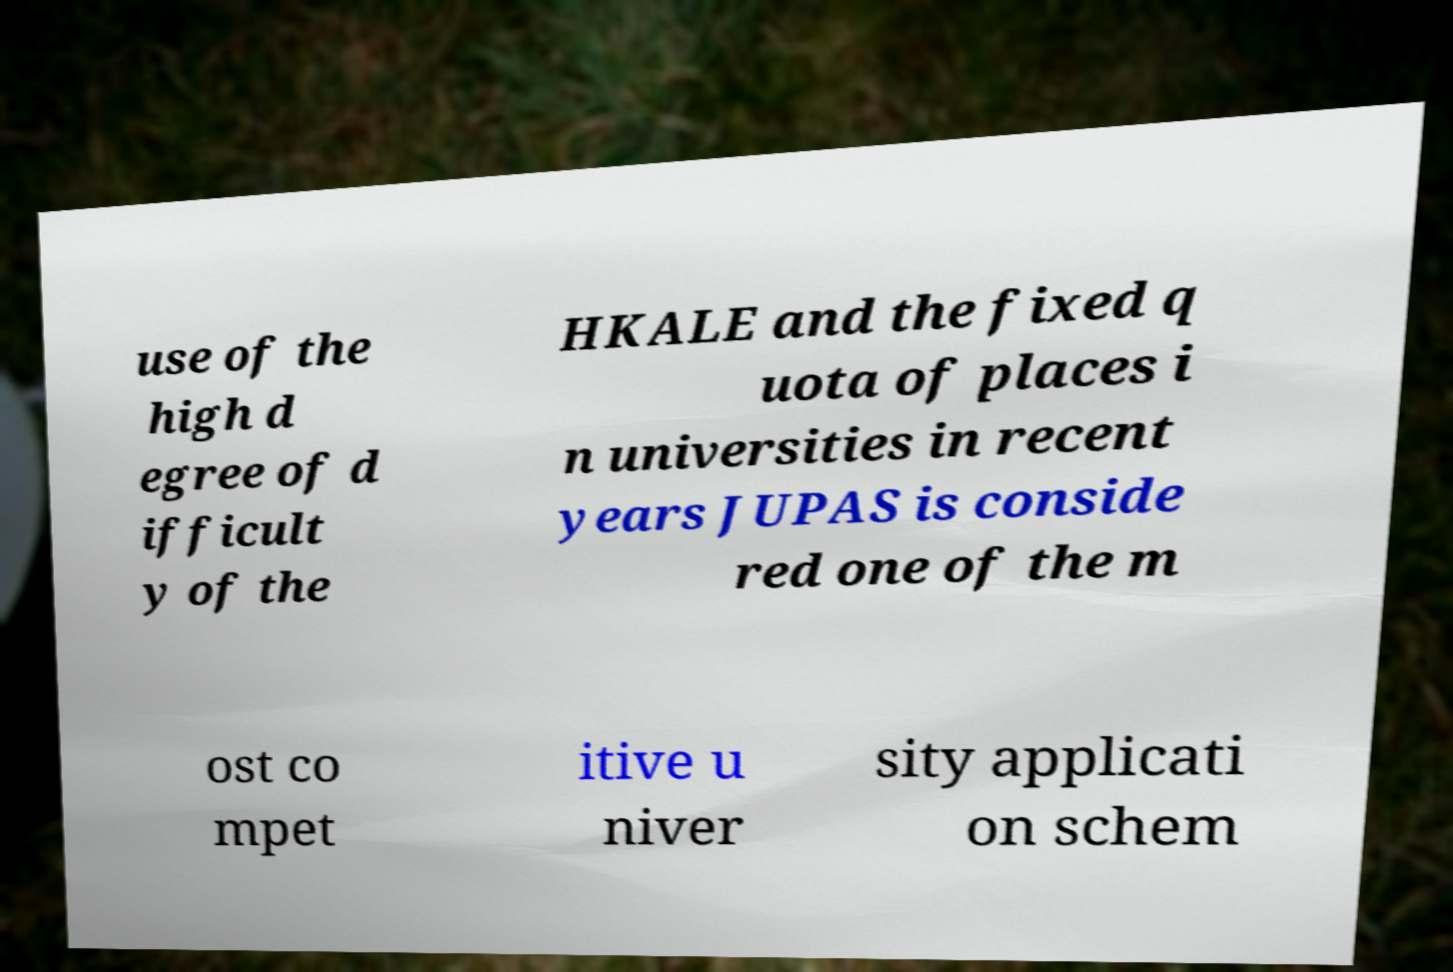Can you read and provide the text displayed in the image?This photo seems to have some interesting text. Can you extract and type it out for me? use of the high d egree of d ifficult y of the HKALE and the fixed q uota of places i n universities in recent years JUPAS is conside red one of the m ost co mpet itive u niver sity applicati on schem 